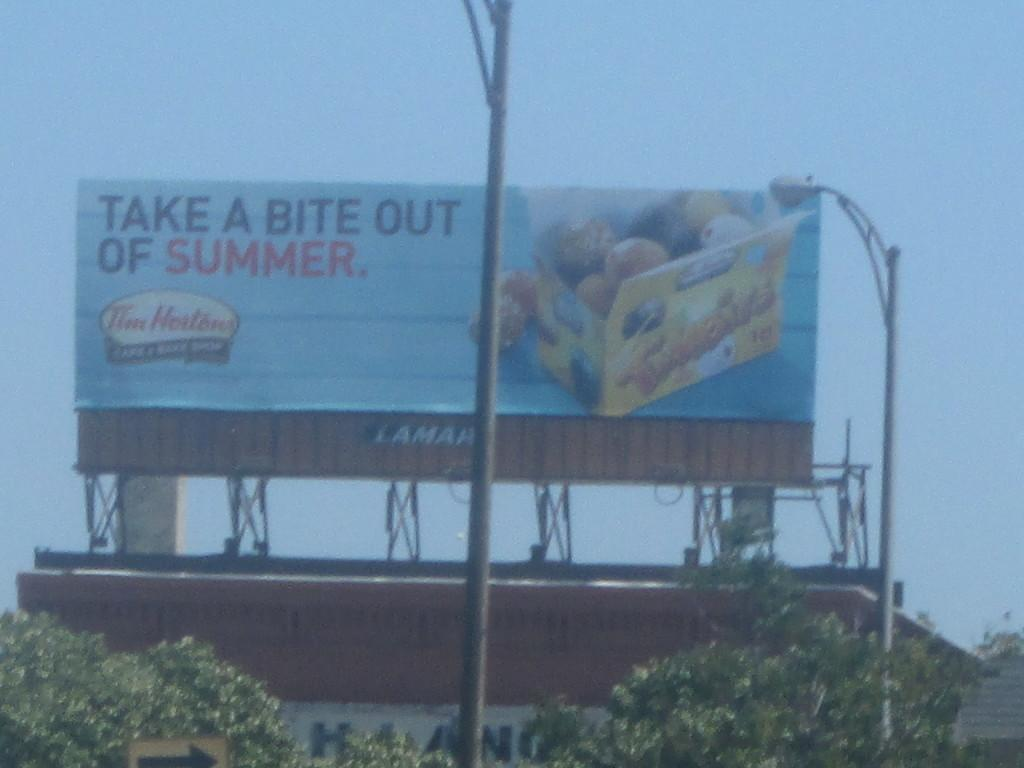<image>
Describe the image concisely. a billboard that says 'take a bite out of summer' 